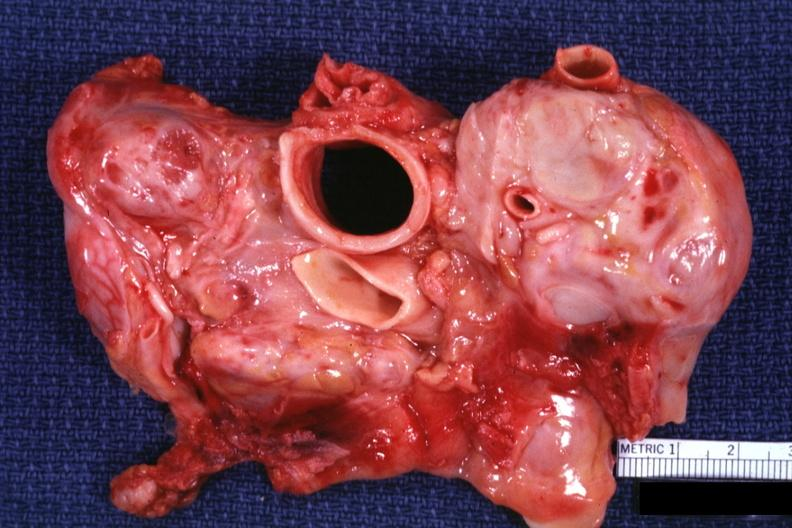what does this image show?
Answer the question using a single word or phrase. Cross section trachea and aorta with massive node metastases can not see cava could be a lymphoma also 